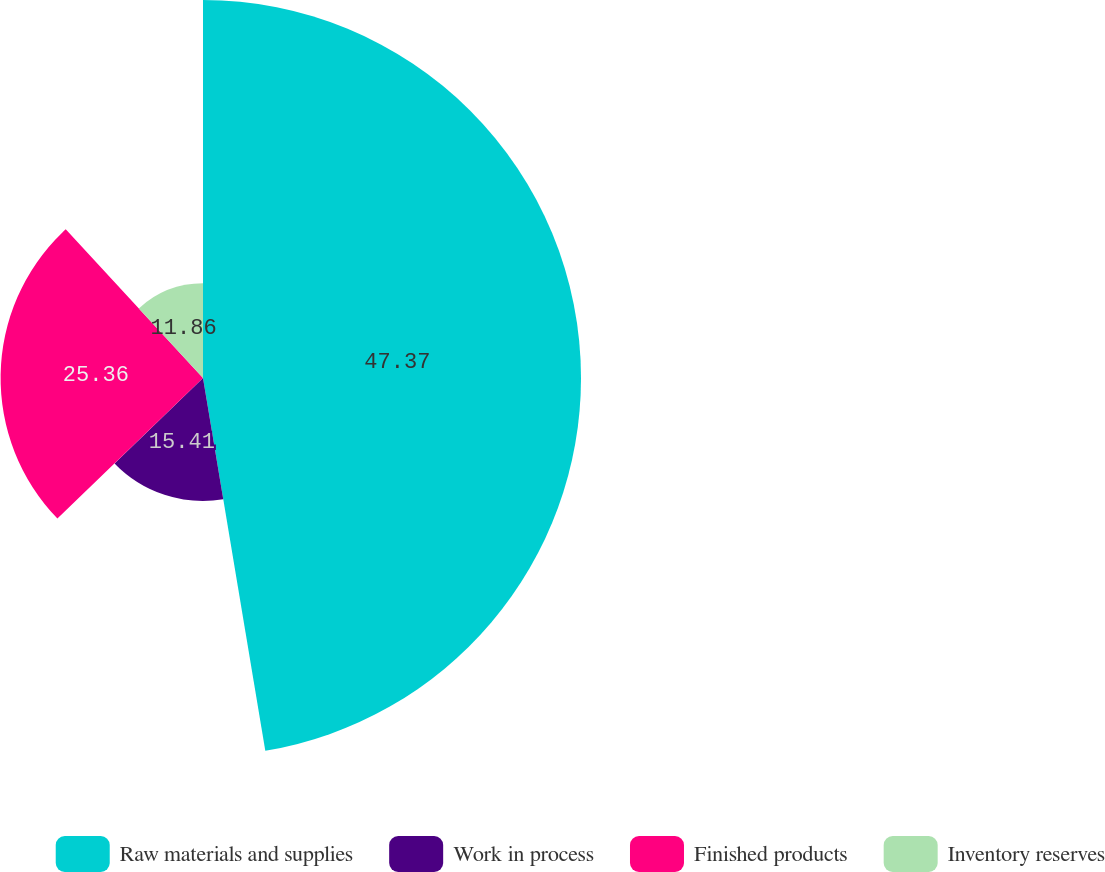Convert chart. <chart><loc_0><loc_0><loc_500><loc_500><pie_chart><fcel>Raw materials and supplies<fcel>Work in process<fcel>Finished products<fcel>Inventory reserves<nl><fcel>47.36%<fcel>15.41%<fcel>25.36%<fcel>11.86%<nl></chart> 